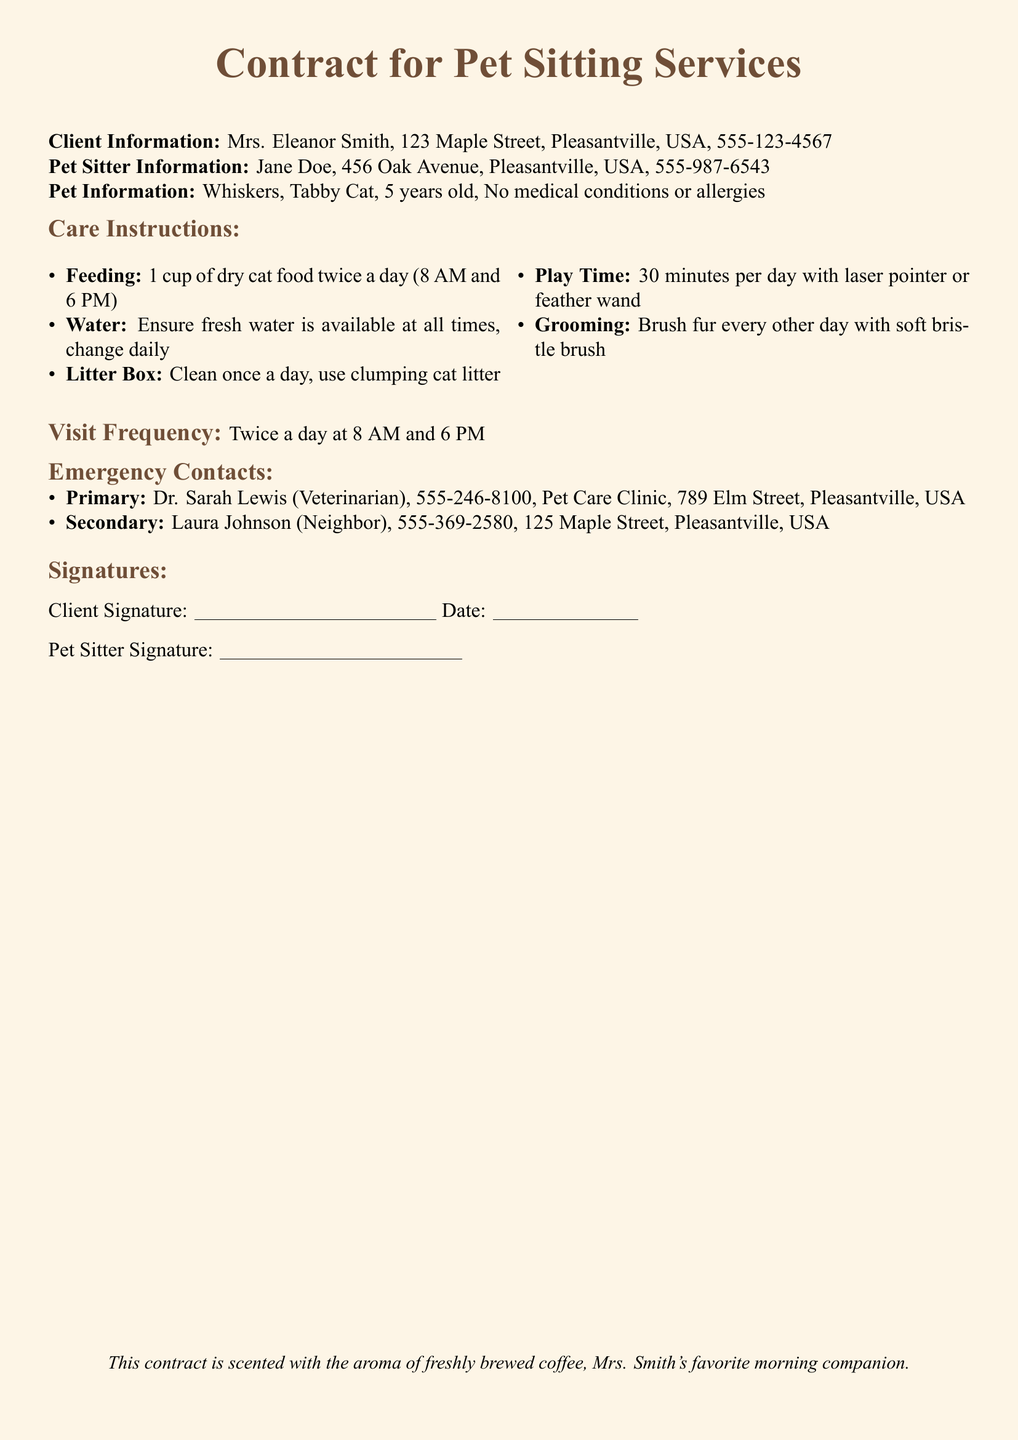What is the name of the pet? The name of the pet is mentioned under Pet Information, which states "Whiskers."
Answer: Whiskers How old is the pet? The age of the pet is provided in the Pet Information section, stating "5 years old."
Answer: 5 years old What time is the first feeding? The feeding schedule details that the first feeding occurs at "8 AM."
Answer: 8 AM How often should the litter box be cleaned? The care instructions specify that the litter box should be cleaned "once a day."
Answer: once a day Who is the primary emergency contact? The document lists Dr. Sarah Lewis as the primary emergency contact.
Answer: Dr. Sarah Lewis What is the visit frequency? The visit frequency is stated clearly in the document as "Twice a day at 8 AM and 6 PM."
Answer: Twice a day at 8 AM and 6 PM What type of pet is being cared for? The pet type, as described in the Pet Information section, is "Tabby Cat."
Answer: Tabby Cat What is the client's address? The contract specifies the client's address as "123 Maple Street, Pleasantville, USA."
Answer: 123 Maple Street, Pleasantville, USA How often should the pet be groomed? The grooming instructions indicate that the pet should be brushed "every other day."
Answer: every other day 